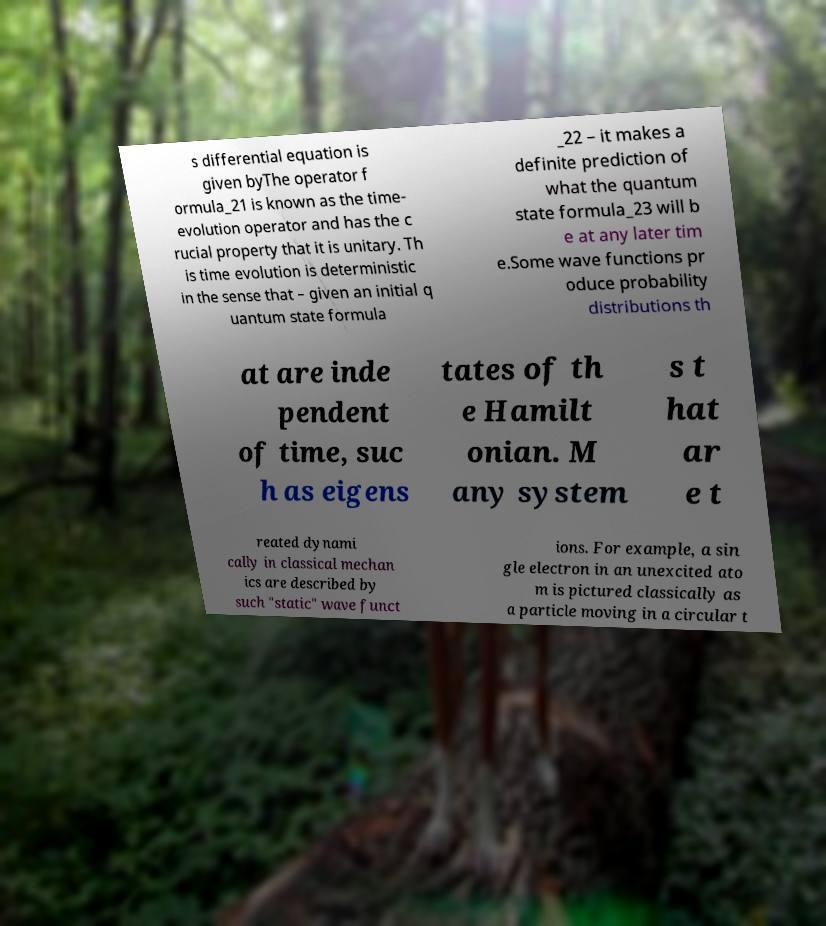Please identify and transcribe the text found in this image. s differential equation is given byThe operator f ormula_21 is known as the time- evolution operator and has the c rucial property that it is unitary. Th is time evolution is deterministic in the sense that – given an initial q uantum state formula _22 – it makes a definite prediction of what the quantum state formula_23 will b e at any later tim e.Some wave functions pr oduce probability distributions th at are inde pendent of time, suc h as eigens tates of th e Hamilt onian. M any system s t hat ar e t reated dynami cally in classical mechan ics are described by such "static" wave funct ions. For example, a sin gle electron in an unexcited ato m is pictured classically as a particle moving in a circular t 